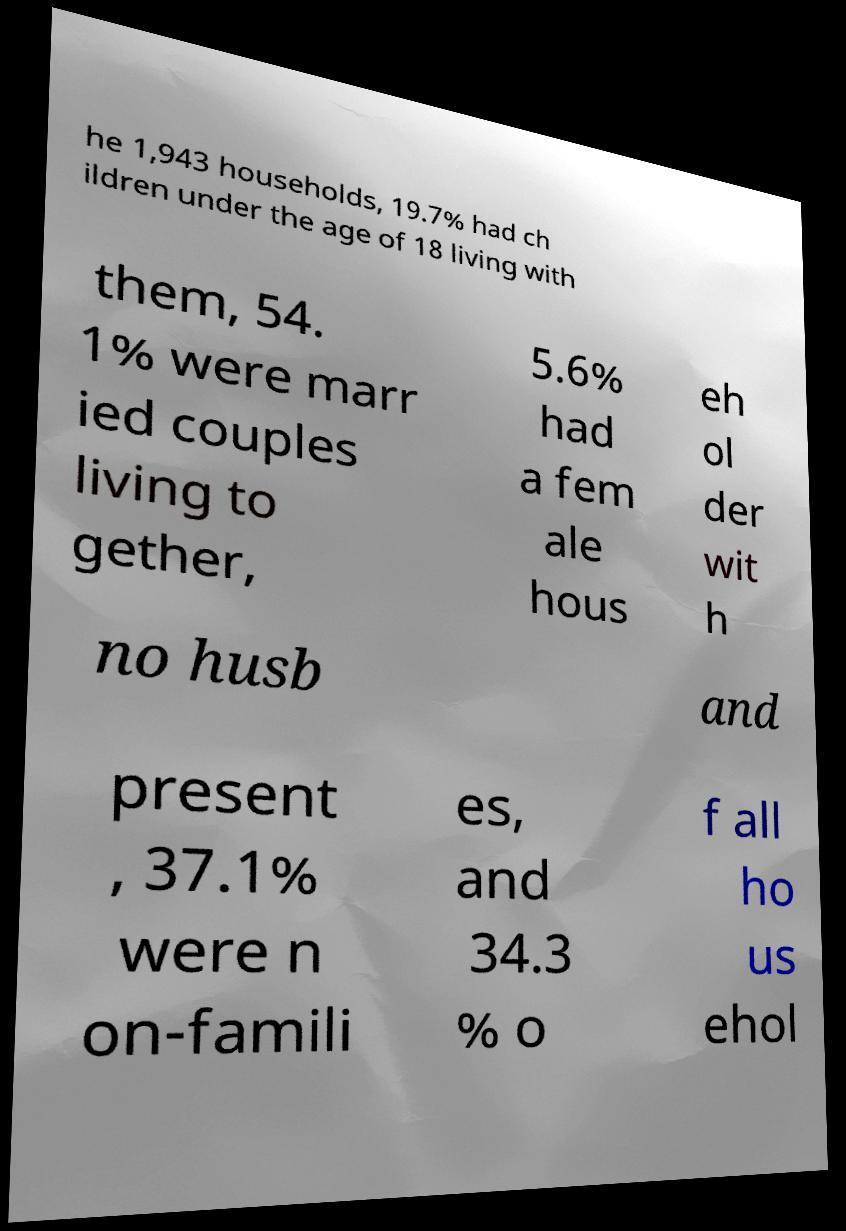Could you assist in decoding the text presented in this image and type it out clearly? he 1,943 households, 19.7% had ch ildren under the age of 18 living with them, 54. 1% were marr ied couples living to gether, 5.6% had a fem ale hous eh ol der wit h no husb and present , 37.1% were n on-famili es, and 34.3 % o f all ho us ehol 